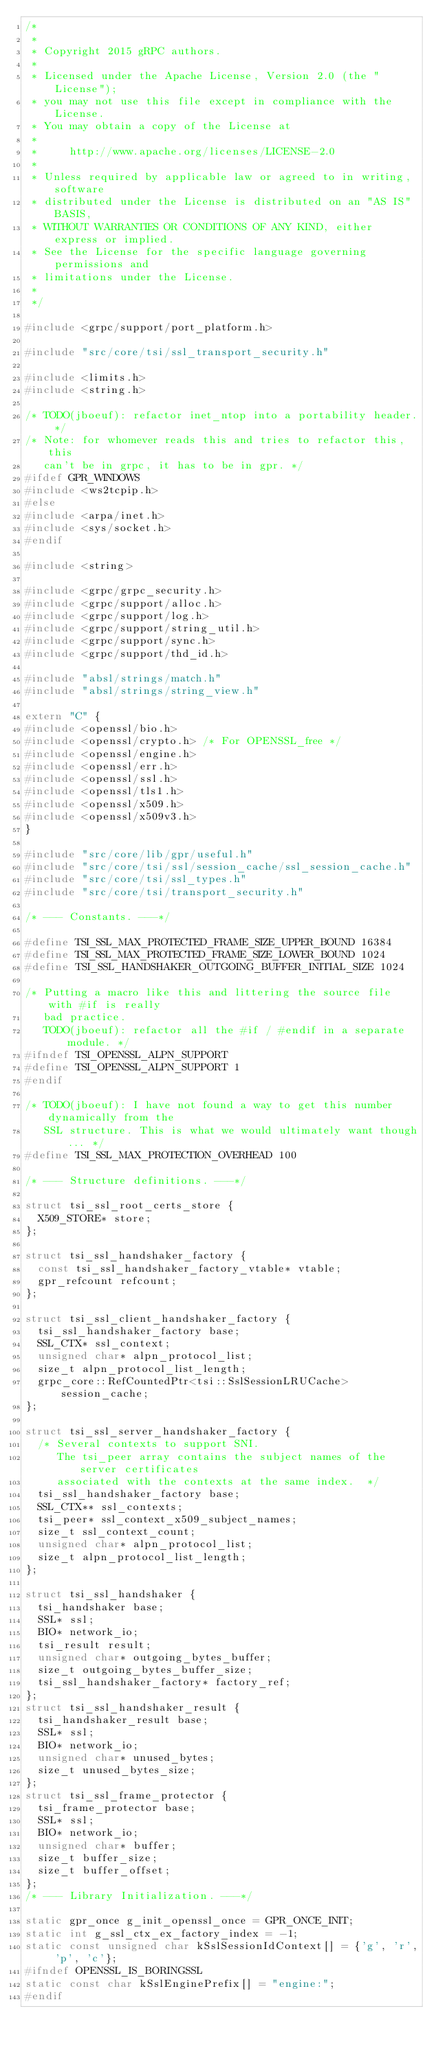<code> <loc_0><loc_0><loc_500><loc_500><_C++_>/*
 *
 * Copyright 2015 gRPC authors.
 *
 * Licensed under the Apache License, Version 2.0 (the "License");
 * you may not use this file except in compliance with the License.
 * You may obtain a copy of the License at
 *
 *     http://www.apache.org/licenses/LICENSE-2.0
 *
 * Unless required by applicable law or agreed to in writing, software
 * distributed under the License is distributed on an "AS IS" BASIS,
 * WITHOUT WARRANTIES OR CONDITIONS OF ANY KIND, either express or implied.
 * See the License for the specific language governing permissions and
 * limitations under the License.
 *
 */

#include <grpc/support/port_platform.h>

#include "src/core/tsi/ssl_transport_security.h"

#include <limits.h>
#include <string.h>

/* TODO(jboeuf): refactor inet_ntop into a portability header. */
/* Note: for whomever reads this and tries to refactor this, this
   can't be in grpc, it has to be in gpr. */
#ifdef GPR_WINDOWS
#include <ws2tcpip.h>
#else
#include <arpa/inet.h>
#include <sys/socket.h>
#endif

#include <string>

#include <grpc/grpc_security.h>
#include <grpc/support/alloc.h>
#include <grpc/support/log.h>
#include <grpc/support/string_util.h>
#include <grpc/support/sync.h>
#include <grpc/support/thd_id.h>

#include "absl/strings/match.h"
#include "absl/strings/string_view.h"

extern "C" {
#include <openssl/bio.h>
#include <openssl/crypto.h> /* For OPENSSL_free */
#include <openssl/engine.h>
#include <openssl/err.h>
#include <openssl/ssl.h>
#include <openssl/tls1.h>
#include <openssl/x509.h>
#include <openssl/x509v3.h>
}

#include "src/core/lib/gpr/useful.h"
#include "src/core/tsi/ssl/session_cache/ssl_session_cache.h"
#include "src/core/tsi/ssl_types.h"
#include "src/core/tsi/transport_security.h"

/* --- Constants. ---*/

#define TSI_SSL_MAX_PROTECTED_FRAME_SIZE_UPPER_BOUND 16384
#define TSI_SSL_MAX_PROTECTED_FRAME_SIZE_LOWER_BOUND 1024
#define TSI_SSL_HANDSHAKER_OUTGOING_BUFFER_INITIAL_SIZE 1024

/* Putting a macro like this and littering the source file with #if is really
   bad practice.
   TODO(jboeuf): refactor all the #if / #endif in a separate module. */
#ifndef TSI_OPENSSL_ALPN_SUPPORT
#define TSI_OPENSSL_ALPN_SUPPORT 1
#endif

/* TODO(jboeuf): I have not found a way to get this number dynamically from the
   SSL structure. This is what we would ultimately want though... */
#define TSI_SSL_MAX_PROTECTION_OVERHEAD 100

/* --- Structure definitions. ---*/

struct tsi_ssl_root_certs_store {
  X509_STORE* store;
};

struct tsi_ssl_handshaker_factory {
  const tsi_ssl_handshaker_factory_vtable* vtable;
  gpr_refcount refcount;
};

struct tsi_ssl_client_handshaker_factory {
  tsi_ssl_handshaker_factory base;
  SSL_CTX* ssl_context;
  unsigned char* alpn_protocol_list;
  size_t alpn_protocol_list_length;
  grpc_core::RefCountedPtr<tsi::SslSessionLRUCache> session_cache;
};

struct tsi_ssl_server_handshaker_factory {
  /* Several contexts to support SNI.
     The tsi_peer array contains the subject names of the server certificates
     associated with the contexts at the same index.  */
  tsi_ssl_handshaker_factory base;
  SSL_CTX** ssl_contexts;
  tsi_peer* ssl_context_x509_subject_names;
  size_t ssl_context_count;
  unsigned char* alpn_protocol_list;
  size_t alpn_protocol_list_length;
};

struct tsi_ssl_handshaker {
  tsi_handshaker base;
  SSL* ssl;
  BIO* network_io;
  tsi_result result;
  unsigned char* outgoing_bytes_buffer;
  size_t outgoing_bytes_buffer_size;
  tsi_ssl_handshaker_factory* factory_ref;
};
struct tsi_ssl_handshaker_result {
  tsi_handshaker_result base;
  SSL* ssl;
  BIO* network_io;
  unsigned char* unused_bytes;
  size_t unused_bytes_size;
};
struct tsi_ssl_frame_protector {
  tsi_frame_protector base;
  SSL* ssl;
  BIO* network_io;
  unsigned char* buffer;
  size_t buffer_size;
  size_t buffer_offset;
};
/* --- Library Initialization. ---*/

static gpr_once g_init_openssl_once = GPR_ONCE_INIT;
static int g_ssl_ctx_ex_factory_index = -1;
static const unsigned char kSslSessionIdContext[] = {'g', 'r', 'p', 'c'};
#ifndef OPENSSL_IS_BORINGSSL
static const char kSslEnginePrefix[] = "engine:";
#endif
</code> 